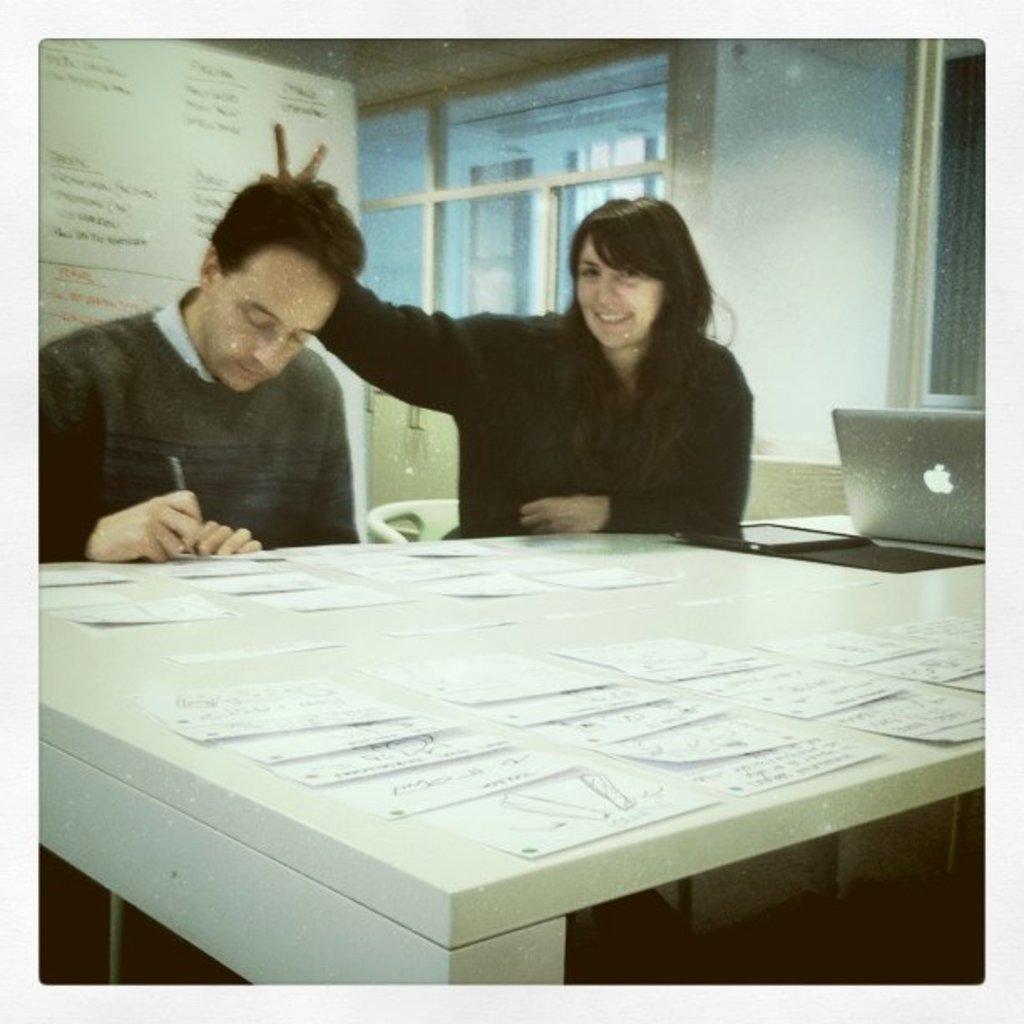In one or two sentences, can you explain what this image depicts? This picture shows a man and woman seated on the chairs and there is a laptop on the table. 